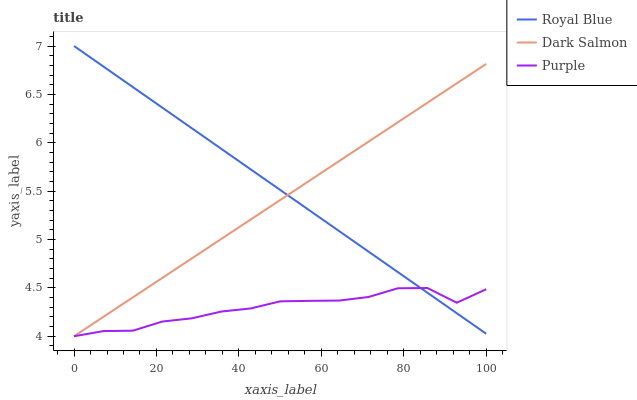Does Purple have the minimum area under the curve?
Answer yes or no. Yes. Does Royal Blue have the maximum area under the curve?
Answer yes or no. Yes. Does Dark Salmon have the minimum area under the curve?
Answer yes or no. No. Does Dark Salmon have the maximum area under the curve?
Answer yes or no. No. Is Royal Blue the smoothest?
Answer yes or no. Yes. Is Purple the roughest?
Answer yes or no. Yes. Is Dark Salmon the smoothest?
Answer yes or no. No. Is Dark Salmon the roughest?
Answer yes or no. No. Does Purple have the lowest value?
Answer yes or no. Yes. Does Royal Blue have the lowest value?
Answer yes or no. No. Does Royal Blue have the highest value?
Answer yes or no. Yes. Does Dark Salmon have the highest value?
Answer yes or no. No. Does Royal Blue intersect Dark Salmon?
Answer yes or no. Yes. Is Royal Blue less than Dark Salmon?
Answer yes or no. No. Is Royal Blue greater than Dark Salmon?
Answer yes or no. No. 